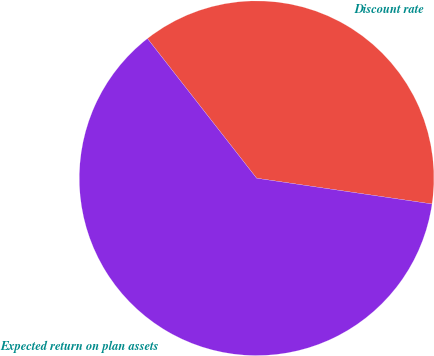Convert chart. <chart><loc_0><loc_0><loc_500><loc_500><pie_chart><fcel>Discount rate<fcel>Expected return on plan assets<nl><fcel>37.88%<fcel>62.12%<nl></chart> 